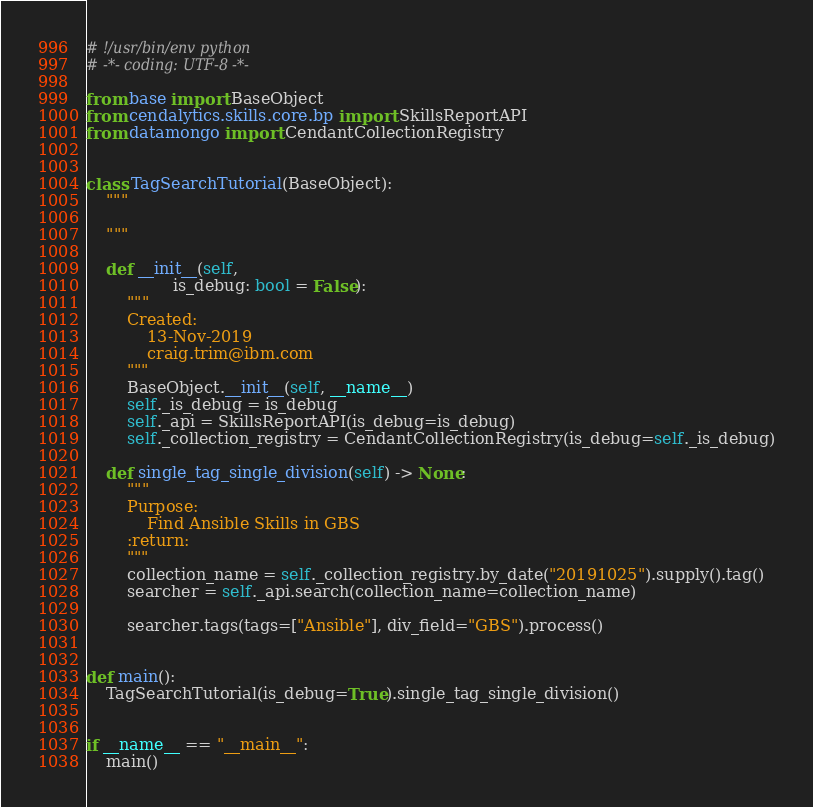Convert code to text. <code><loc_0><loc_0><loc_500><loc_500><_Python_># !/usr/bin/env python
# -*- coding: UTF-8 -*-

from base import BaseObject
from cendalytics.skills.core.bp import SkillsReportAPI
from datamongo import CendantCollectionRegistry


class TagSearchTutorial(BaseObject):
    """

    """

    def __init__(self,
                 is_debug: bool = False):
        """
        Created:
            13-Nov-2019
            craig.trim@ibm.com
        """
        BaseObject.__init__(self, __name__)
        self._is_debug = is_debug
        self._api = SkillsReportAPI(is_debug=is_debug)
        self._collection_registry = CendantCollectionRegistry(is_debug=self._is_debug)

    def single_tag_single_division(self) -> None:
        """
        Purpose:
            Find Ansible Skills in GBS
        :return:
        """
        collection_name = self._collection_registry.by_date("20191025").supply().tag()
        searcher = self._api.search(collection_name=collection_name)

        searcher.tags(tags=["Ansible"], div_field="GBS").process()


def main():
    TagSearchTutorial(is_debug=True).single_tag_single_division()


if __name__ == "__main__":
    main()
</code> 